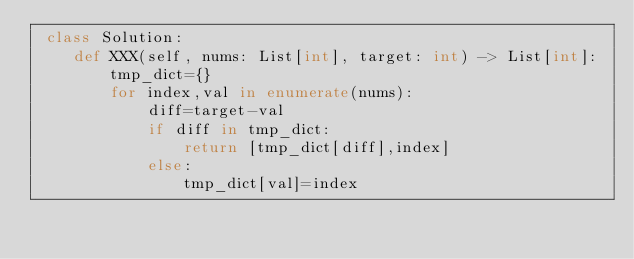Convert code to text. <code><loc_0><loc_0><loc_500><loc_500><_Python_> class Solution:
    def XXX(self, nums: List[int], target: int) -> List[int]:
        tmp_dict={}
        for index,val in enumerate(nums):
            diff=target-val
            if diff in tmp_dict:
                return [tmp_dict[diff],index]
            else:
                tmp_dict[val]=index

</code> 